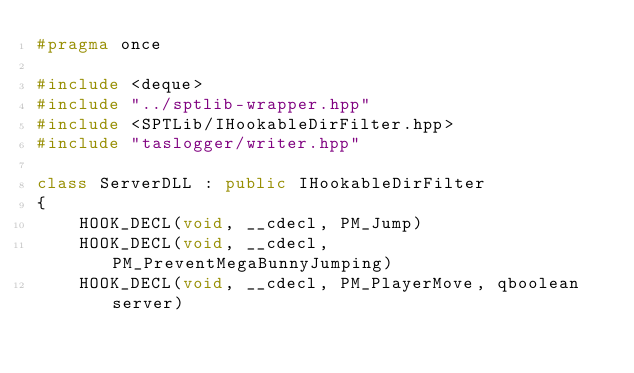Convert code to text. <code><loc_0><loc_0><loc_500><loc_500><_C++_>#pragma once

#include <deque>
#include "../sptlib-wrapper.hpp"
#include <SPTLib/IHookableDirFilter.hpp>
#include "taslogger/writer.hpp"

class ServerDLL : public IHookableDirFilter
{
	HOOK_DECL(void, __cdecl, PM_Jump)
	HOOK_DECL(void, __cdecl, PM_PreventMegaBunnyJumping)
	HOOK_DECL(void, __cdecl, PM_PlayerMove, qboolean server)</code> 